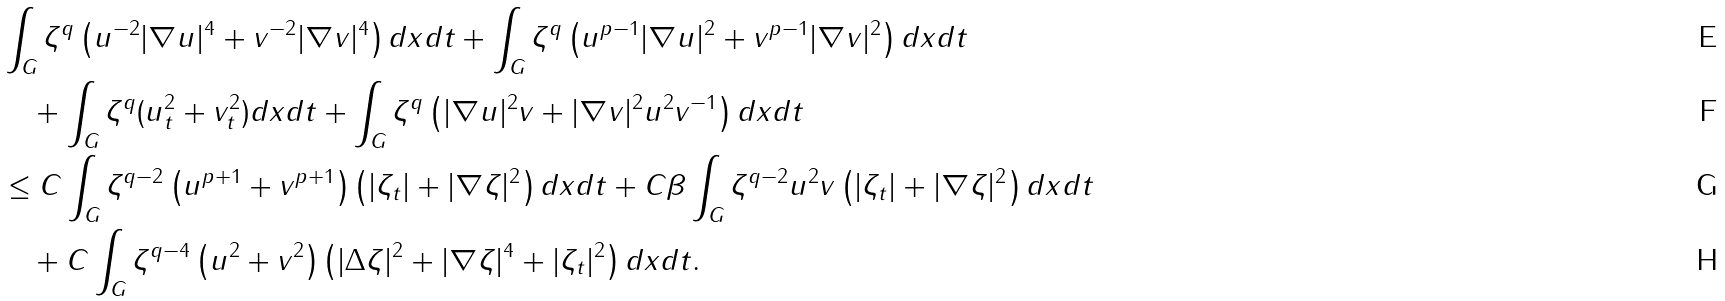<formula> <loc_0><loc_0><loc_500><loc_500>& \int _ { G } \zeta ^ { q } \left ( u ^ { - 2 } | \nabla u | ^ { 4 } + v ^ { - 2 } | \nabla v | ^ { 4 } \right ) d x d t + \int _ { G } \zeta ^ { q } \left ( u ^ { p - 1 } | \nabla u | ^ { 2 } + v ^ { p - 1 } | \nabla v | ^ { 2 } \right ) d x d t \\ & \quad + \int _ { G } \zeta ^ { q } ( u _ { t } ^ { 2 } + v _ { t } ^ { 2 } ) d x d t + \int _ { G } \zeta ^ { q } \left ( | \nabla u | ^ { 2 } v + | \nabla v | ^ { 2 } u ^ { 2 } v ^ { - 1 } \right ) d x d t \\ & \leq C \int _ { G } \zeta ^ { q - 2 } \left ( u ^ { p + 1 } + v ^ { p + 1 } \right ) \left ( | \zeta _ { t } | + | \nabla \zeta | ^ { 2 } \right ) d x d t + C \beta \int _ { G } \zeta ^ { q - 2 } u ^ { 2 } v \left ( | \zeta _ { t } | + | \nabla \zeta | ^ { 2 } \right ) d x d t \\ & \quad + C \int _ { G } \zeta ^ { q - 4 } \left ( u ^ { 2 } + v ^ { 2 } \right ) \left ( | \Delta \zeta | ^ { 2 } + | \nabla \zeta | ^ { 4 } + | \zeta _ { t } | ^ { 2 } \right ) d x d t .</formula> 